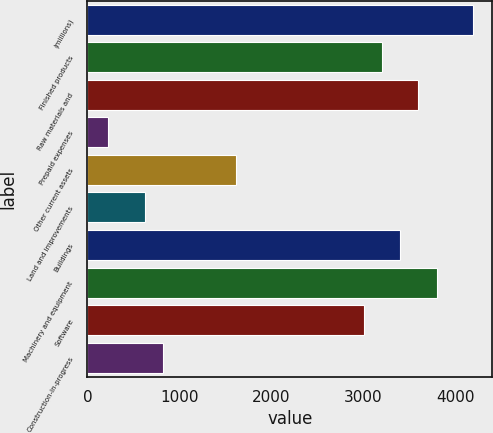Convert chart. <chart><loc_0><loc_0><loc_500><loc_500><bar_chart><fcel>(millions)<fcel>Finished products<fcel>Raw materials and<fcel>Prepaid expenses<fcel>Other current assets<fcel>Land and improvements<fcel>Buildings<fcel>Machinery and equipment<fcel>Software<fcel>Construction-in-progress<nl><fcel>4193.96<fcel>3202.16<fcel>3598.88<fcel>226.76<fcel>1615.28<fcel>623.48<fcel>3400.52<fcel>3797.24<fcel>3003.8<fcel>821.84<nl></chart> 